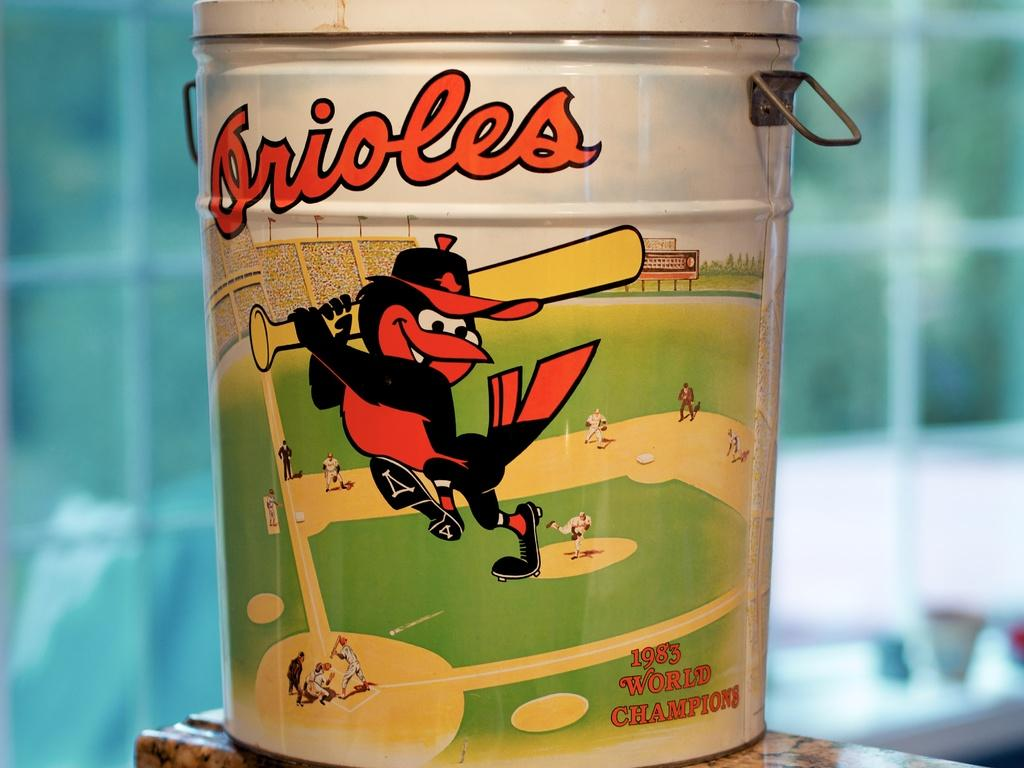<image>
Present a compact description of the photo's key features. A tin of something from the 1983 world champion Orioles. 